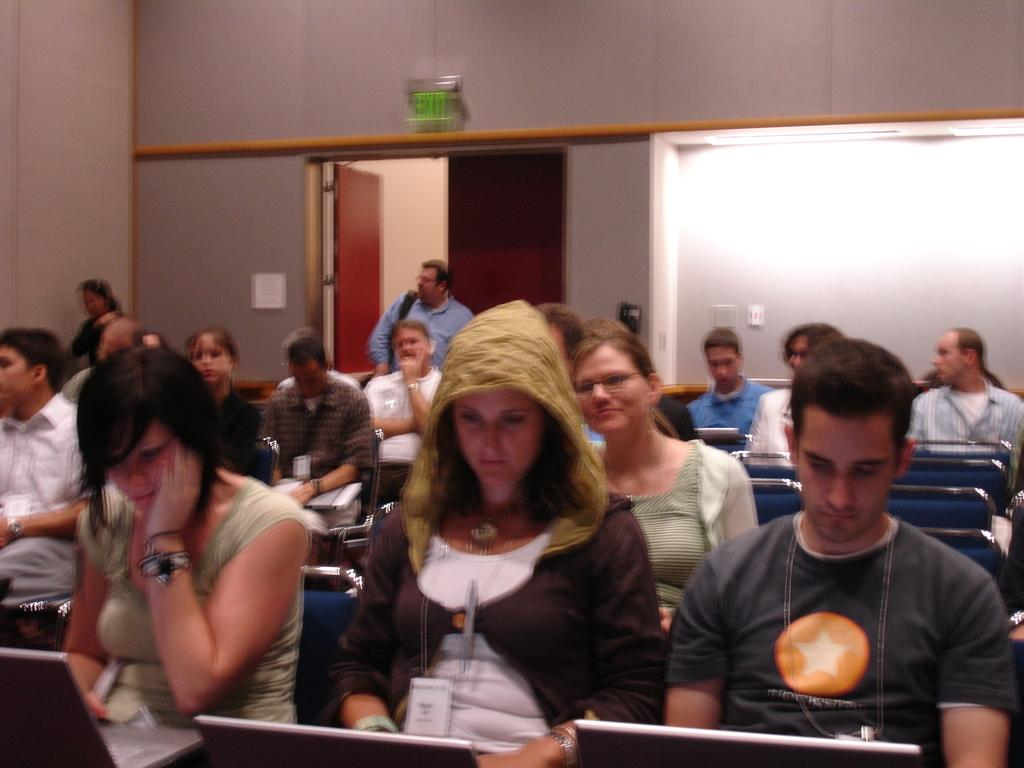What are the people in the image doing? The people in the image are sitting on chairs and holding laptops. Can you describe the setting of the image? There are there any architectural features visible? Is there anyone else in the image besides the people sitting on chairs? Yes, there is a person on the floor in the background of the image. What type of argument can be heard between the people in the image? There is no indication of an argument in the image; the people are simply sitting on chairs and holding laptops. Can you see any volcanoes in the image? No, there are no volcanoes present in the image. 